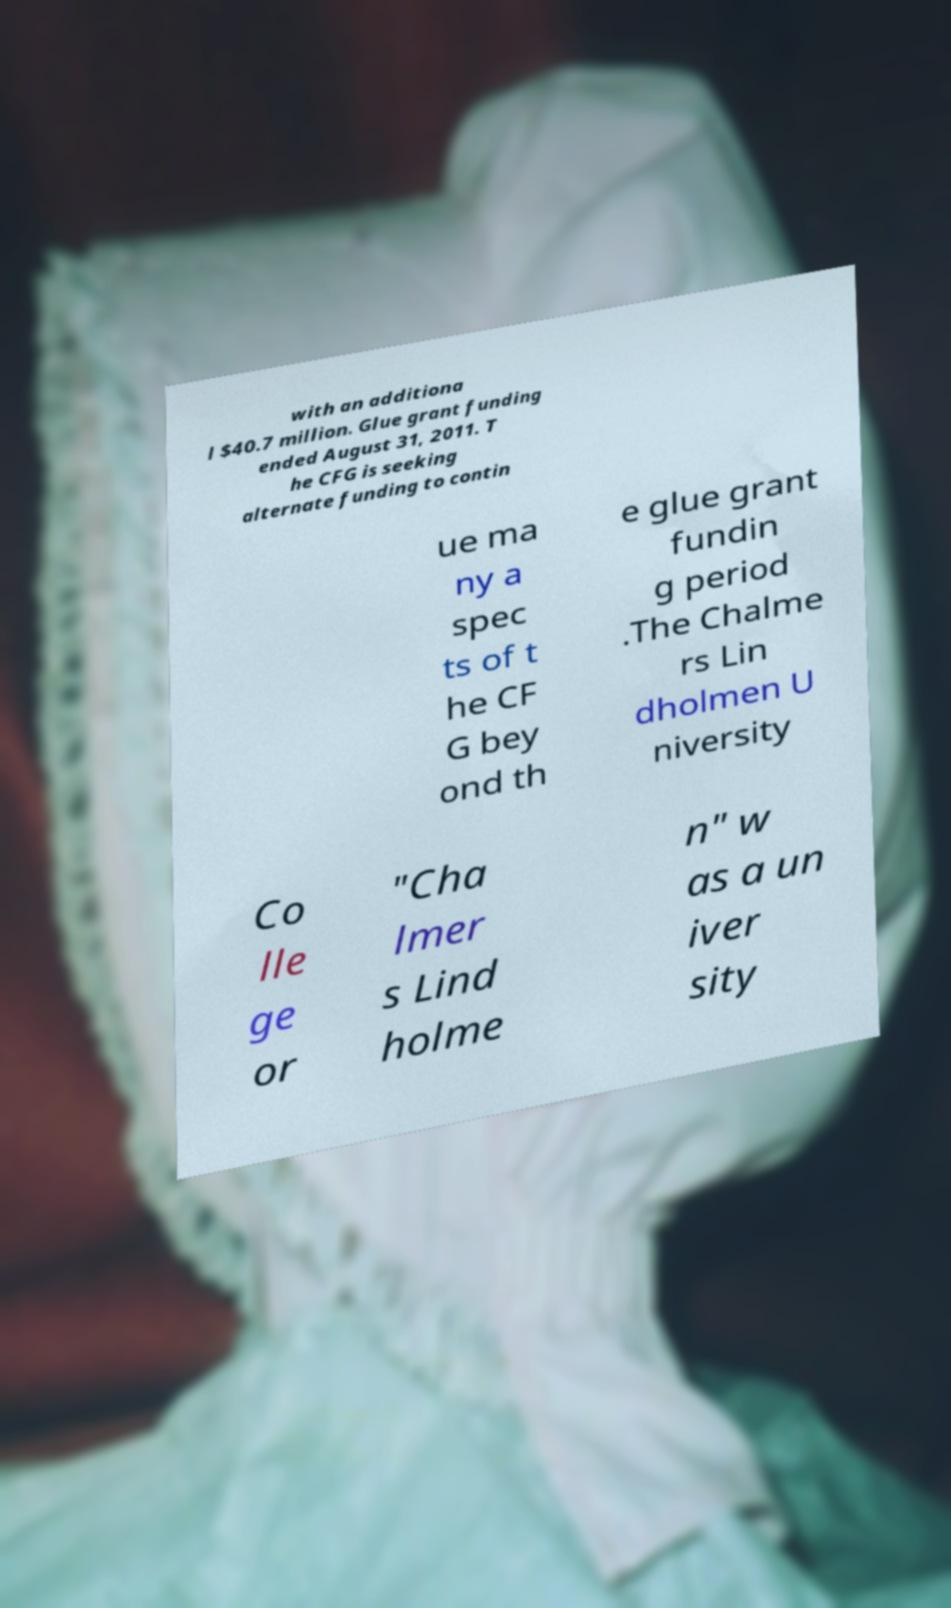For documentation purposes, I need the text within this image transcribed. Could you provide that? with an additiona l $40.7 million. Glue grant funding ended August 31, 2011. T he CFG is seeking alternate funding to contin ue ma ny a spec ts of t he CF G bey ond th e glue grant fundin g period .The Chalme rs Lin dholmen U niversity Co lle ge or "Cha lmer s Lind holme n" w as a un iver sity 